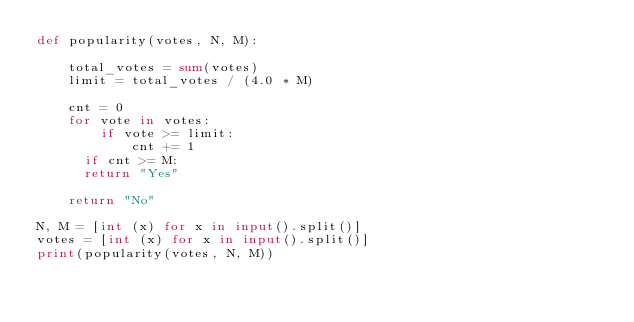Convert code to text. <code><loc_0><loc_0><loc_500><loc_500><_Python_>def popularity(votes, N, M):
    
    total_votes = sum(votes)
    limit = total_votes / (4.0 * M)
    
    cnt = 0
    for vote in votes:
        if vote >= limit:
            cnt += 1
    	if cnt >= M:
			return "Yes"
    
    return "No"
  
N, M = [int (x) for x in input().split()]
votes = [int (x) for x in input().split()]
print(popularity(votes, N, M))
</code> 